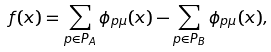Convert formula to latex. <formula><loc_0><loc_0><loc_500><loc_500>f ( x ) = \sum _ { p \in P _ { A } } \phi _ { p \mu } ( x ) - \sum _ { p \in P _ { B } } \phi _ { p \mu } ( x ) ,</formula> 